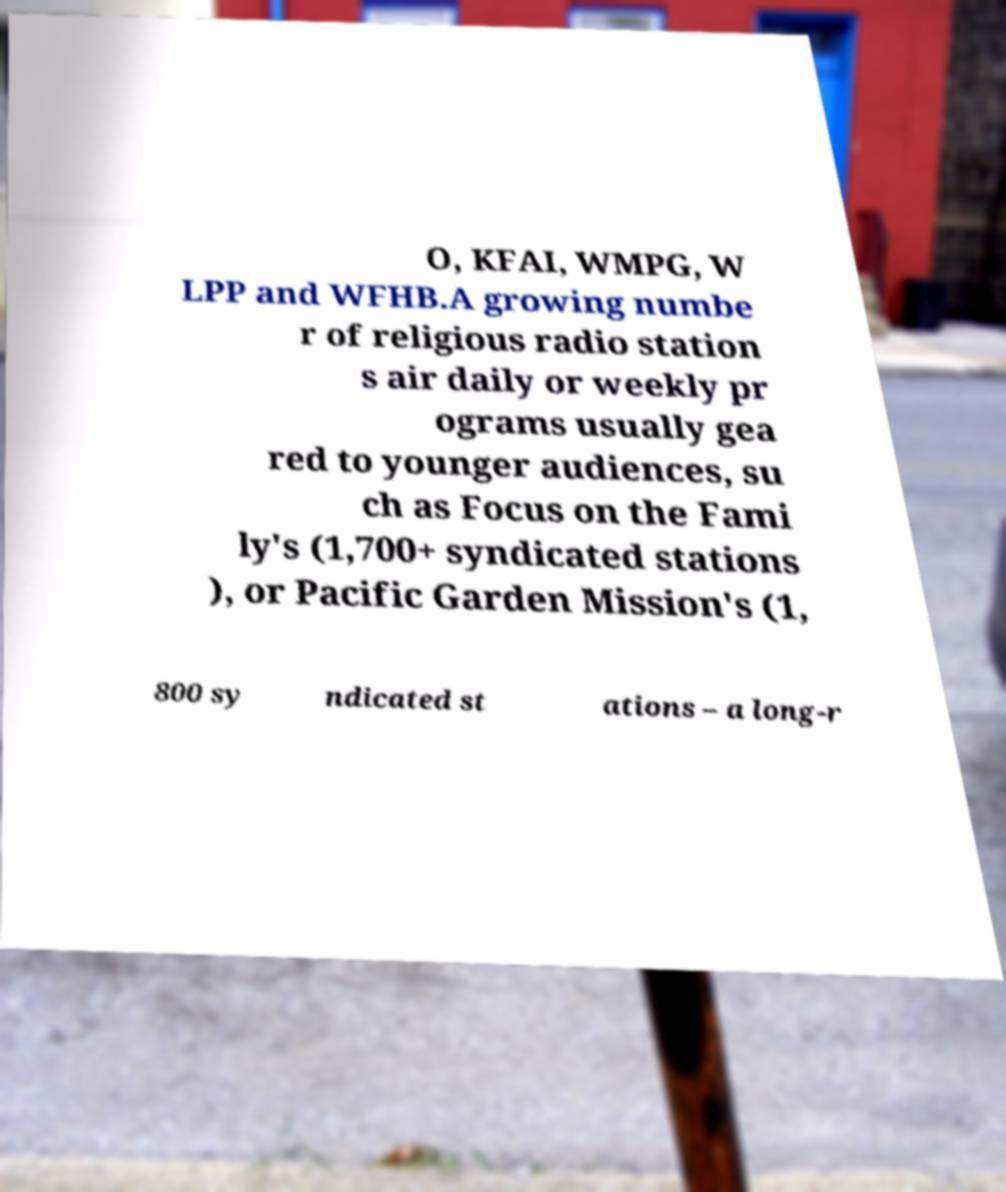Please identify and transcribe the text found in this image. O, KFAI, WMPG, W LPP and WFHB.A growing numbe r of religious radio station s air daily or weekly pr ograms usually gea red to younger audiences, su ch as Focus on the Fami ly's (1,700+ syndicated stations ), or Pacific Garden Mission's (1, 800 sy ndicated st ations – a long-r 